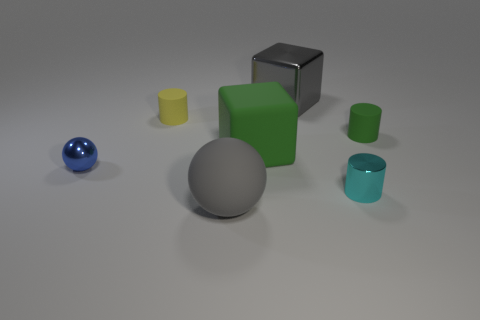There is a sphere that is in front of the cyan thing; does it have the same color as the large metallic block?
Ensure brevity in your answer.  Yes. Is there anything else that has the same color as the metallic block?
Provide a succinct answer. Yes. There is a matte object that is the same color as the large rubber block; what shape is it?
Offer a very short reply. Cylinder. There is a thing that is the same color as the rubber ball; what is its size?
Your answer should be compact. Large. There is a metallic cube; is it the same color as the matte sphere in front of the tiny blue metallic thing?
Keep it short and to the point. Yes. There is a matte thing that is in front of the blue shiny sphere; is it the same color as the shiny thing behind the small blue ball?
Your answer should be compact. Yes. There is a yellow object that is the same shape as the tiny green matte thing; what material is it?
Your answer should be very brief. Rubber. How many shiny blocks have the same color as the large rubber ball?
Keep it short and to the point. 1. What size is the green cube that is made of the same material as the big gray sphere?
Your answer should be compact. Large. What number of red things are metal cubes or small metal things?
Keep it short and to the point. 0. 